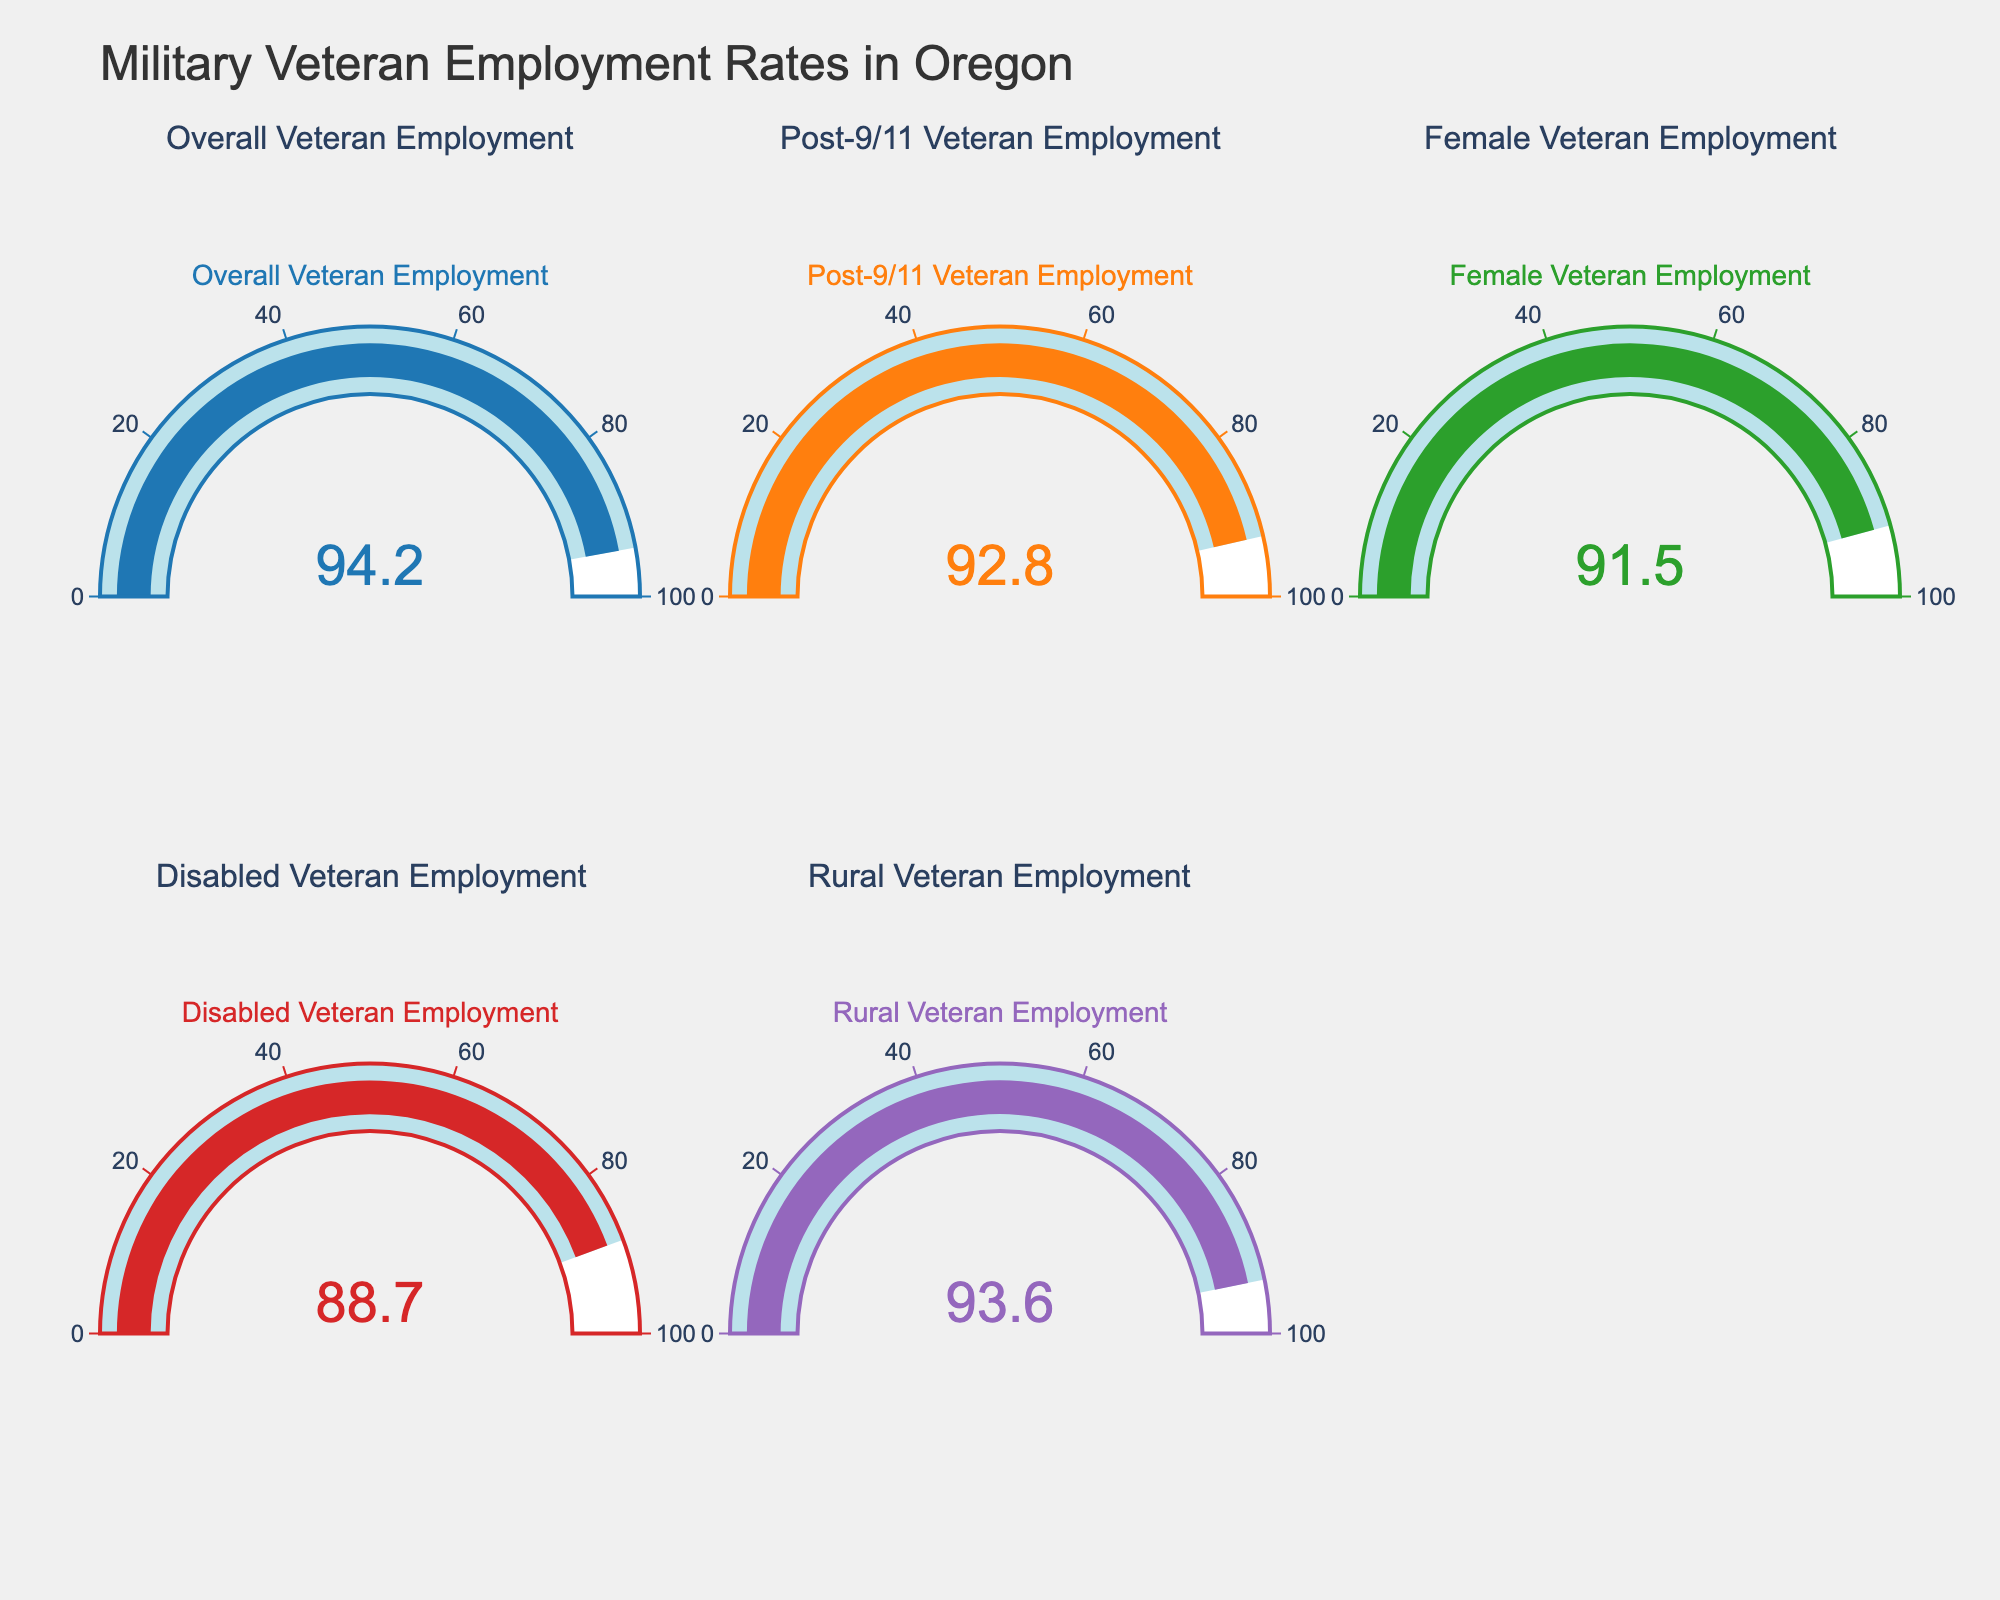How many gauges are displayed in the figure? Count all the gauges shown in the two rows of the figure. There are three in the first row and two in the second row. Hence, there are 5 gauges in total.
Answer: 5 What is the title of the figure? Look at the main title displayed on top of the figure. It reads "Military Veteran Employment Rates in Oregon".
Answer: Military Veteran Employment Rates in Oregon Which category has the highest employment rate? Compare the values shown on all the gauges. The "Overall Veteran Employment" shows 94.2, which is the highest among all categories.
Answer: Overall Veteran Employment What is the difference in employment rate between Female Veterans and Disabled Veterans? The employment rate for Female Veterans is 91.5 and for Disabled Veterans, it is 88.7. The difference is calculated as 91.5 - 88.7.
Answer: 2.8 What is the average employment rate across all categories shown? Sum all the employment rates and divide by the number of categories. 94.2 + 92.8 + 91.5 + 88.7 + 93.6 = 460.8. Divide by 5 to get 460.8 / 5.
Answer: 92.16 Which category has a lower employment rate, Post-9/11 Veterans or Rural Veterans? Compare the values on the respective gauges. Post-9/11 Veterans have a rate of 92.8 while Rural Veterans have 93.6.
Answer: Post-9/11 Veterans What is the total employment rate for all categories combined? Sum all the employment rates listed. Adding them gives 94.2 + 92.8 + 91.5 + 88.7 + 93.6.
Answer: 460.8 How does the employment rate of Female Veterans compare to the overall veterans? Compare the values on the gauges for Female Veteran Employment and Overall Veteran Employment. Female Veterans have 91.5 while Overall Veterans have 94.2.
Answer: Lower Which category has the second lowest employment rate? Arrange all the employment rates in ascending order: 88.7, 91.5, 92.8, 93.6, 94.2. The second lowest rate is for Female Veterans.
Answer: Female Veteran Employment 